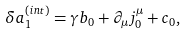Convert formula to latex. <formula><loc_0><loc_0><loc_500><loc_500>\delta a _ { 1 } ^ { ( i n t ) } = \gamma b _ { 0 } + \partial _ { \mu } j _ { 0 } ^ { \mu } + c _ { 0 } ,</formula> 